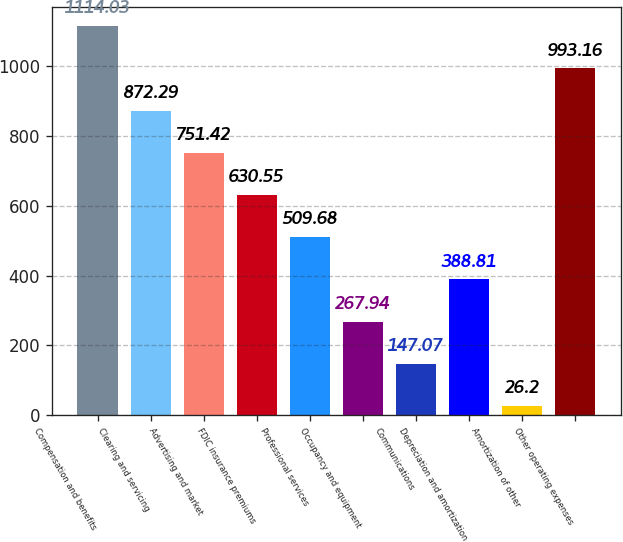<chart> <loc_0><loc_0><loc_500><loc_500><bar_chart><fcel>Compensation and benefits<fcel>Clearing and servicing<fcel>Advertising and market<fcel>FDIC insurance premiums<fcel>Professional services<fcel>Occupancy and equipment<fcel>Communications<fcel>Depreciation and amortization<fcel>Amortization of other<fcel>Other operating expenses<nl><fcel>1114.03<fcel>872.29<fcel>751.42<fcel>630.55<fcel>509.68<fcel>267.94<fcel>147.07<fcel>388.81<fcel>26.2<fcel>993.16<nl></chart> 